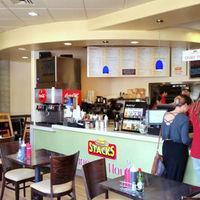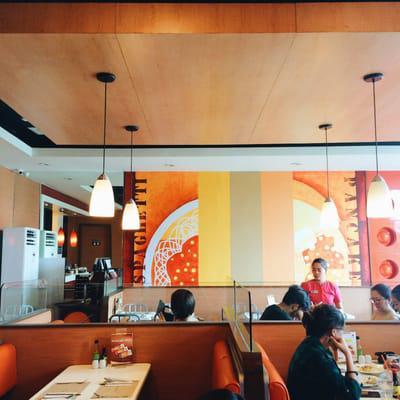The first image is the image on the left, the second image is the image on the right. Assess this claim about the two images: "Someone is reading the menu board.". Correct or not? Answer yes or no. No. 